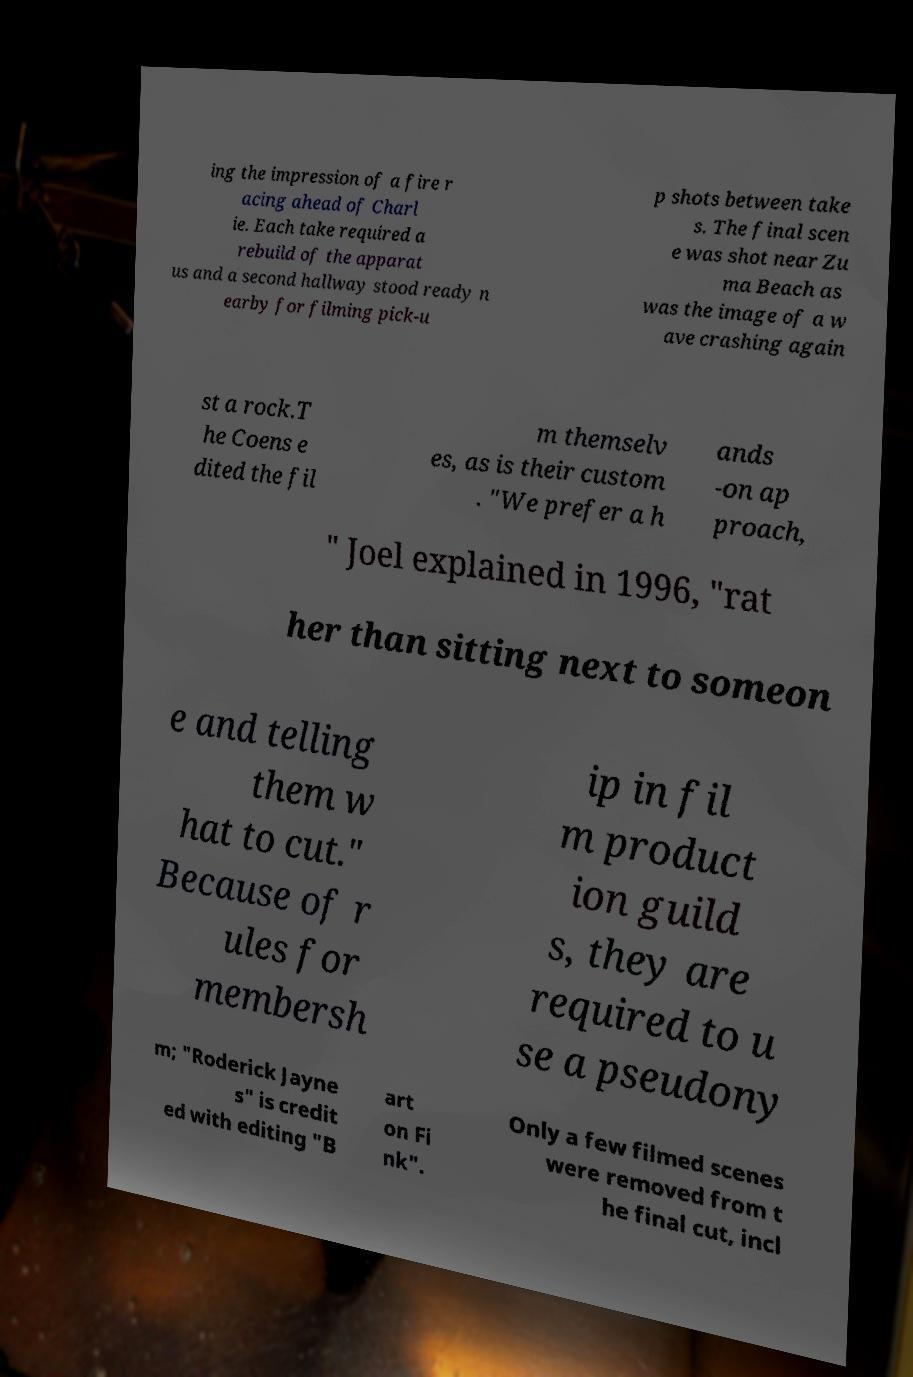There's text embedded in this image that I need extracted. Can you transcribe it verbatim? ing the impression of a fire r acing ahead of Charl ie. Each take required a rebuild of the apparat us and a second hallway stood ready n earby for filming pick-u p shots between take s. The final scen e was shot near Zu ma Beach as was the image of a w ave crashing again st a rock.T he Coens e dited the fil m themselv es, as is their custom . "We prefer a h ands -on ap proach, " Joel explained in 1996, "rat her than sitting next to someon e and telling them w hat to cut." Because of r ules for membersh ip in fil m product ion guild s, they are required to u se a pseudony m; "Roderick Jayne s" is credit ed with editing "B art on Fi nk". Only a few filmed scenes were removed from t he final cut, incl 